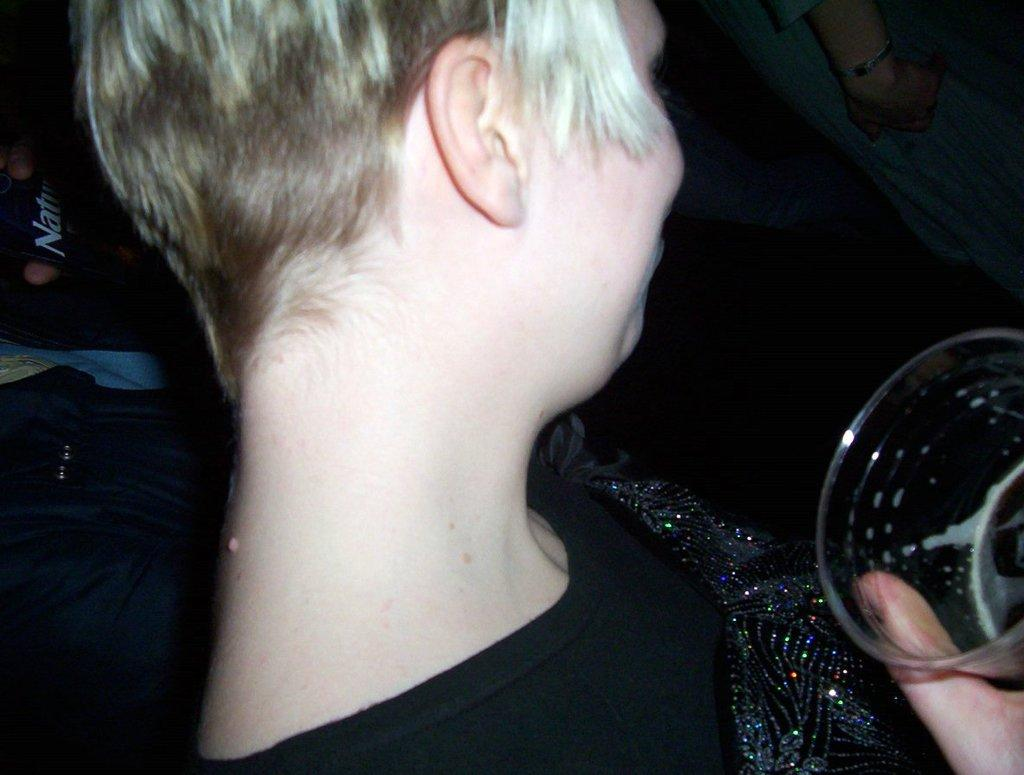What is the main subject of the image? There is a person in the image. What is the person holding in the image? The person is holding a glass. Can you describe the background of the image? There are other persons visible in the background of the image. What type of oven can be seen in the image? There is no oven present in the image. 